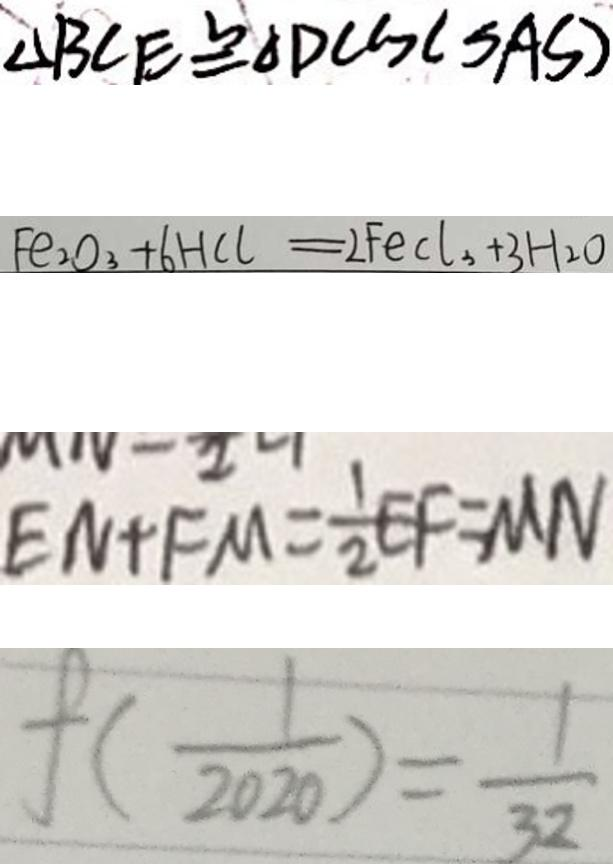<formula> <loc_0><loc_0><loc_500><loc_500>\Delta B C E \cong \Delta D C G ( S A S ) 
 F e _ { 2 } o _ { 3 } + 6 H C l = 2 F e C l _ { 3 } + 3 H _ { 2 } O 
 E N + F M = \frac { 1 } { 2 } E F = M N 
 f ( \frac { 1 } { 2 0 2 0 } ) = \frac { 1 } { 3 2 }</formula> 